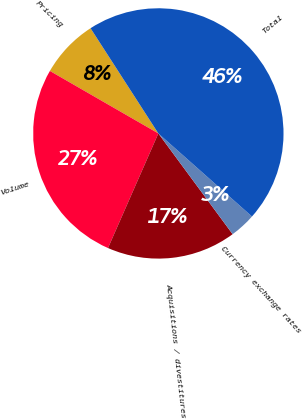Convert chart to OTSL. <chart><loc_0><loc_0><loc_500><loc_500><pie_chart><fcel>Pricing<fcel>Volume<fcel>Acquisitions / divestitures<fcel>Currency exchange rates<fcel>Total<nl><fcel>7.57%<fcel>26.73%<fcel>16.7%<fcel>3.34%<fcel>45.66%<nl></chart> 